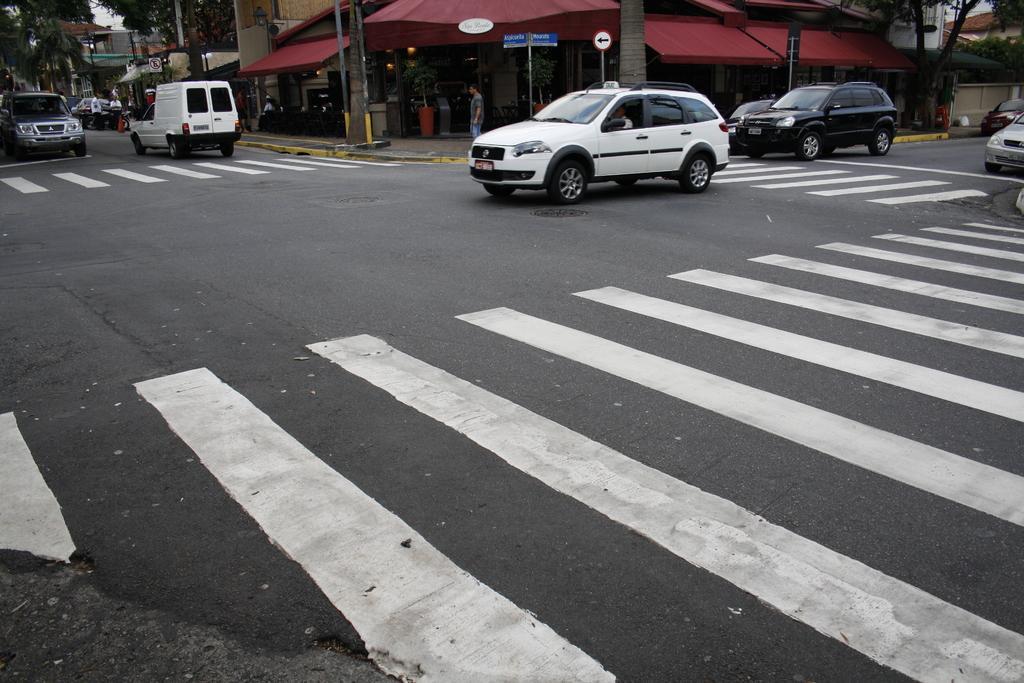Could you give a brief overview of what you see in this image? In this picture there is a view of the road with some white color zebra marking. Behind there are some cars moving on the road. In the background there is a red color roof shed shop and some trees. 